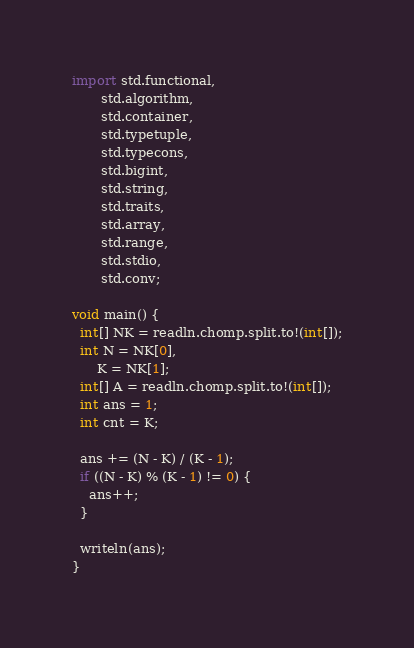Convert code to text. <code><loc_0><loc_0><loc_500><loc_500><_D_>import std.functional,
       std.algorithm,
       std.container,
       std.typetuple,
       std.typecons,
       std.bigint,
       std.string,
       std.traits,
       std.array,
       std.range,
       std.stdio,
       std.conv;

void main() {
  int[] NK = readln.chomp.split.to!(int[]);
  int N = NK[0],
      K = NK[1];
  int[] A = readln.chomp.split.to!(int[]);
  int ans = 1;
  int cnt = K;

  ans += (N - K) / (K - 1);
  if ((N - K) % (K - 1) != 0) {
    ans++;
  }

  writeln(ans);
}
</code> 